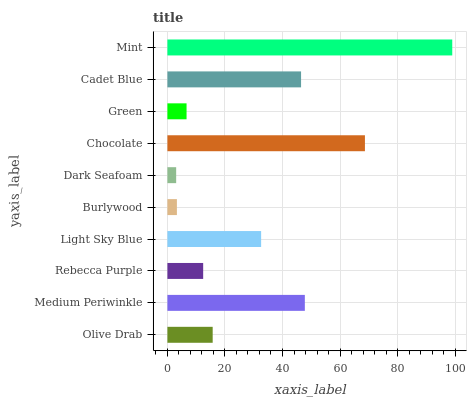Is Dark Seafoam the minimum?
Answer yes or no. Yes. Is Mint the maximum?
Answer yes or no. Yes. Is Medium Periwinkle the minimum?
Answer yes or no. No. Is Medium Periwinkle the maximum?
Answer yes or no. No. Is Medium Periwinkle greater than Olive Drab?
Answer yes or no. Yes. Is Olive Drab less than Medium Periwinkle?
Answer yes or no. Yes. Is Olive Drab greater than Medium Periwinkle?
Answer yes or no. No. Is Medium Periwinkle less than Olive Drab?
Answer yes or no. No. Is Light Sky Blue the high median?
Answer yes or no. Yes. Is Olive Drab the low median?
Answer yes or no. Yes. Is Rebecca Purple the high median?
Answer yes or no. No. Is Chocolate the low median?
Answer yes or no. No. 